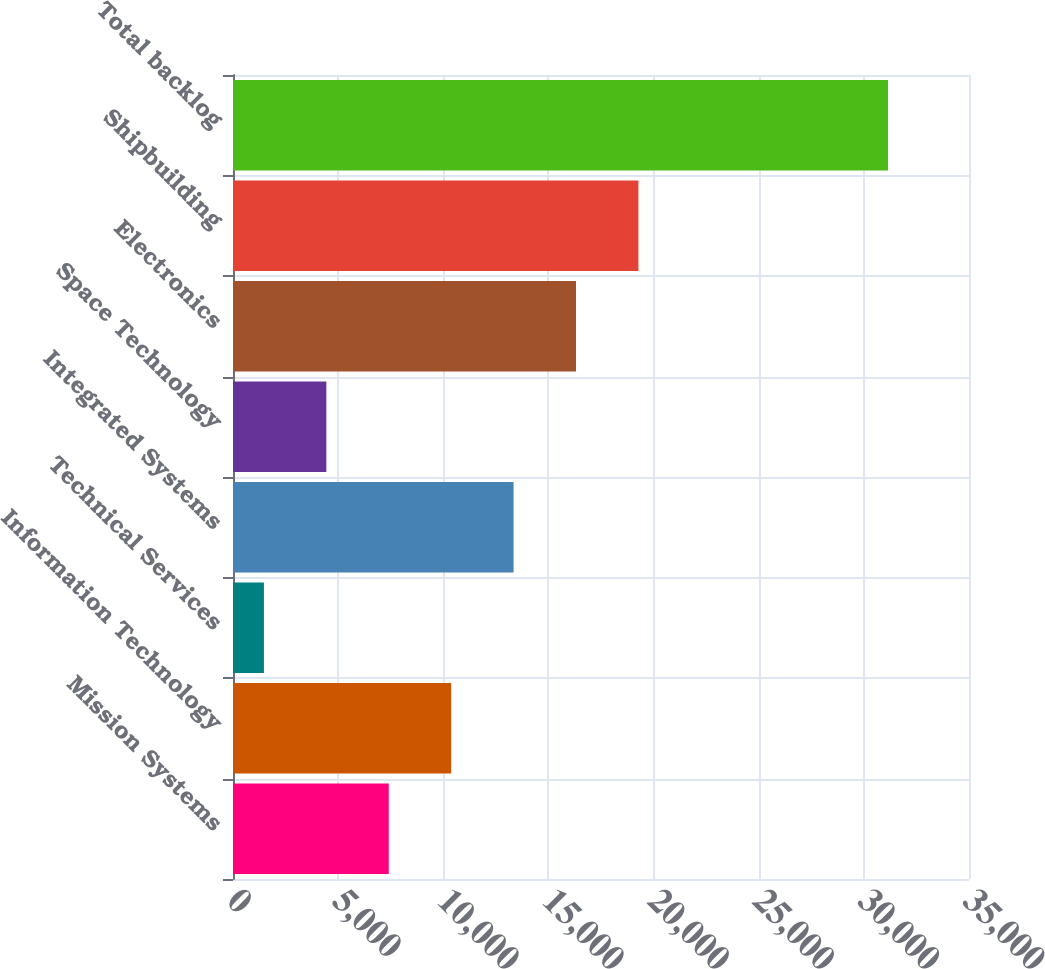<chart> <loc_0><loc_0><loc_500><loc_500><bar_chart><fcel>Mission Systems<fcel>Information Technology<fcel>Technical Services<fcel>Integrated Systems<fcel>Space Technology<fcel>Electronics<fcel>Shipbuilding<fcel>Total backlog<nl><fcel>7407<fcel>10375<fcel>1471<fcel>13343<fcel>4439<fcel>16311<fcel>19279<fcel>31151<nl></chart> 